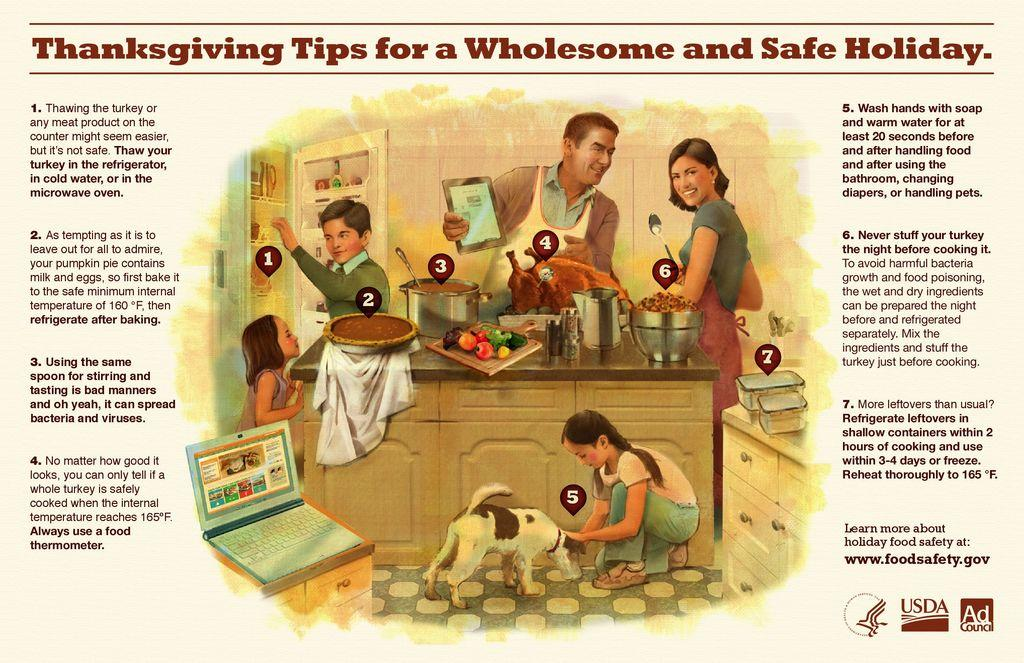<image>
Give a short and clear explanation of the subsequent image. The article help to give tips to have a safe and wholesome holida with family. 